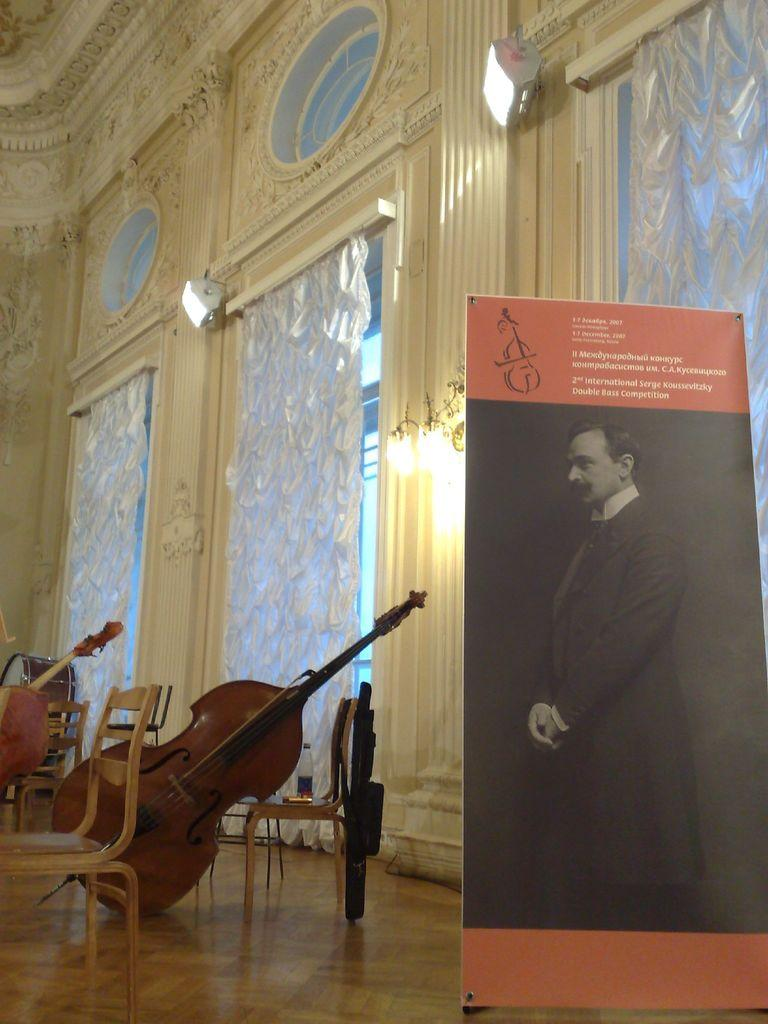What is the main object in the image? There is a flex board in the image. What else can be seen in the image besides the flex board? There are musical instruments on chairs in the image. How many chairs are visible in the image? There are chairs in the image, but the exact number is not specified. What type of glove is being used by the protester in the image? There is no protest or glove present in the image; it features a flex board and musical instruments on chairs. 